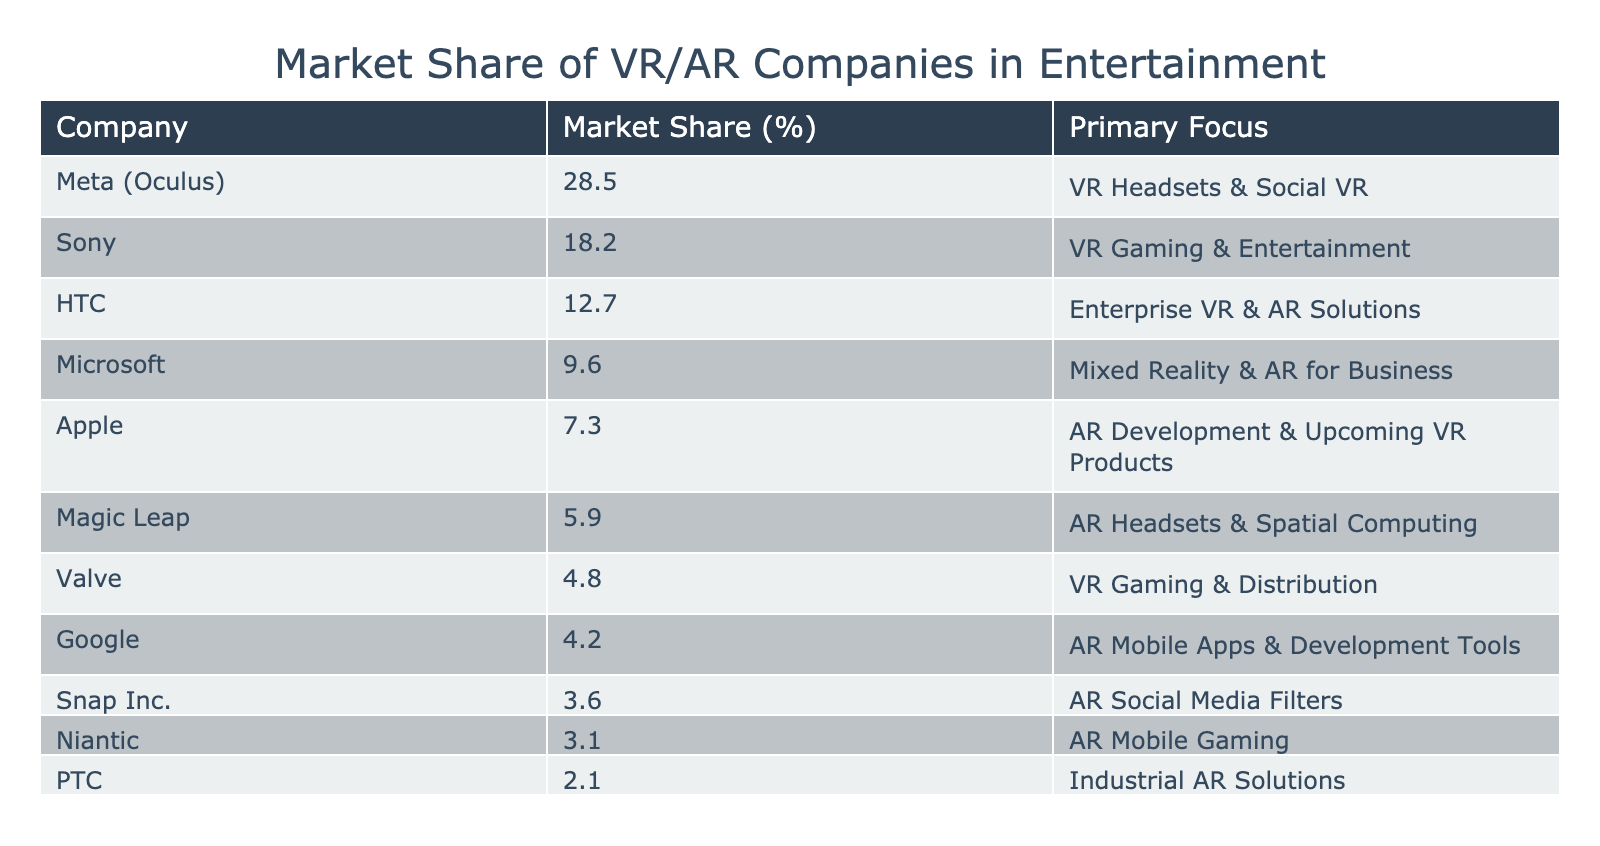What is the market share of Meta (Oculus)? The market share of Meta (Oculus) is explicitly stated in the table under the "Market Share (%)" column, showing 28.5%.
Answer: 28.5% Which company has the least market share in the table? By examining the "Market Share (%)" column, Niantic has the smallest percentage, which is 3.1%.
Answer: Niantic What is the combined market share of the top three companies? The top three companies are Meta (28.5%), Sony (18.2%), and HTC (12.7%). Their combined market share is calculated as 28.5 + 18.2 + 12.7 = 59.4%.
Answer: 59.4% Is Apple's market share greater than or equal to 10%? By checking the "Market Share (%)" column, Apple's market share is 7.3%, which is less than 10%. Thus, the answer is no.
Answer: No Which company focuses on industrial AR solutions? The company specializing in industrial AR solutions is PTC, as noted in the "Primary Focus" column of the table.
Answer: PTC What is the average market share of companies whose primary focus is VR gaming? The companies focusing on VR gaming are Sony (18.2%) and Valve (4.8%). The average is calculated by adding their shares (18.2 + 4.8) = 23%, and then dividing by the number of companies (2): 23%/2 = 11.5%.
Answer: 11.5% Is Google’s market share higher than Snap Inc.'s? Google has a market share of 4.2% and Snap Inc. has a market share of 3.6%. Since 4.2% is greater than 3.6%, the answer is yes.
Answer: Yes If you combine the market shares of the top two companies and compare it with HTC's share, which is larger? The market shares of Meta (28.5%) and Sony (18.2%) add up to 46.7%. Since HTC's share is 12.7%, 46.7% is clearly larger than 12.7%.
Answer: 46.7% What percentage of the market share is occupied by companies whose primary focus is AR? The companies with AR as their primary focus are HTC (12.7%), Microsoft (9.6%), Apple (7.3%), Magic Leap (5.9%), Google (4.2%), Snap Inc. (3.6%), and Niantic (3.1%). Their combined market share is 12.7 + 9.6 + 7.3 + 5.9 + 4.2 + 3.6 + 3.1 = 46.4%.
Answer: 46.4% 